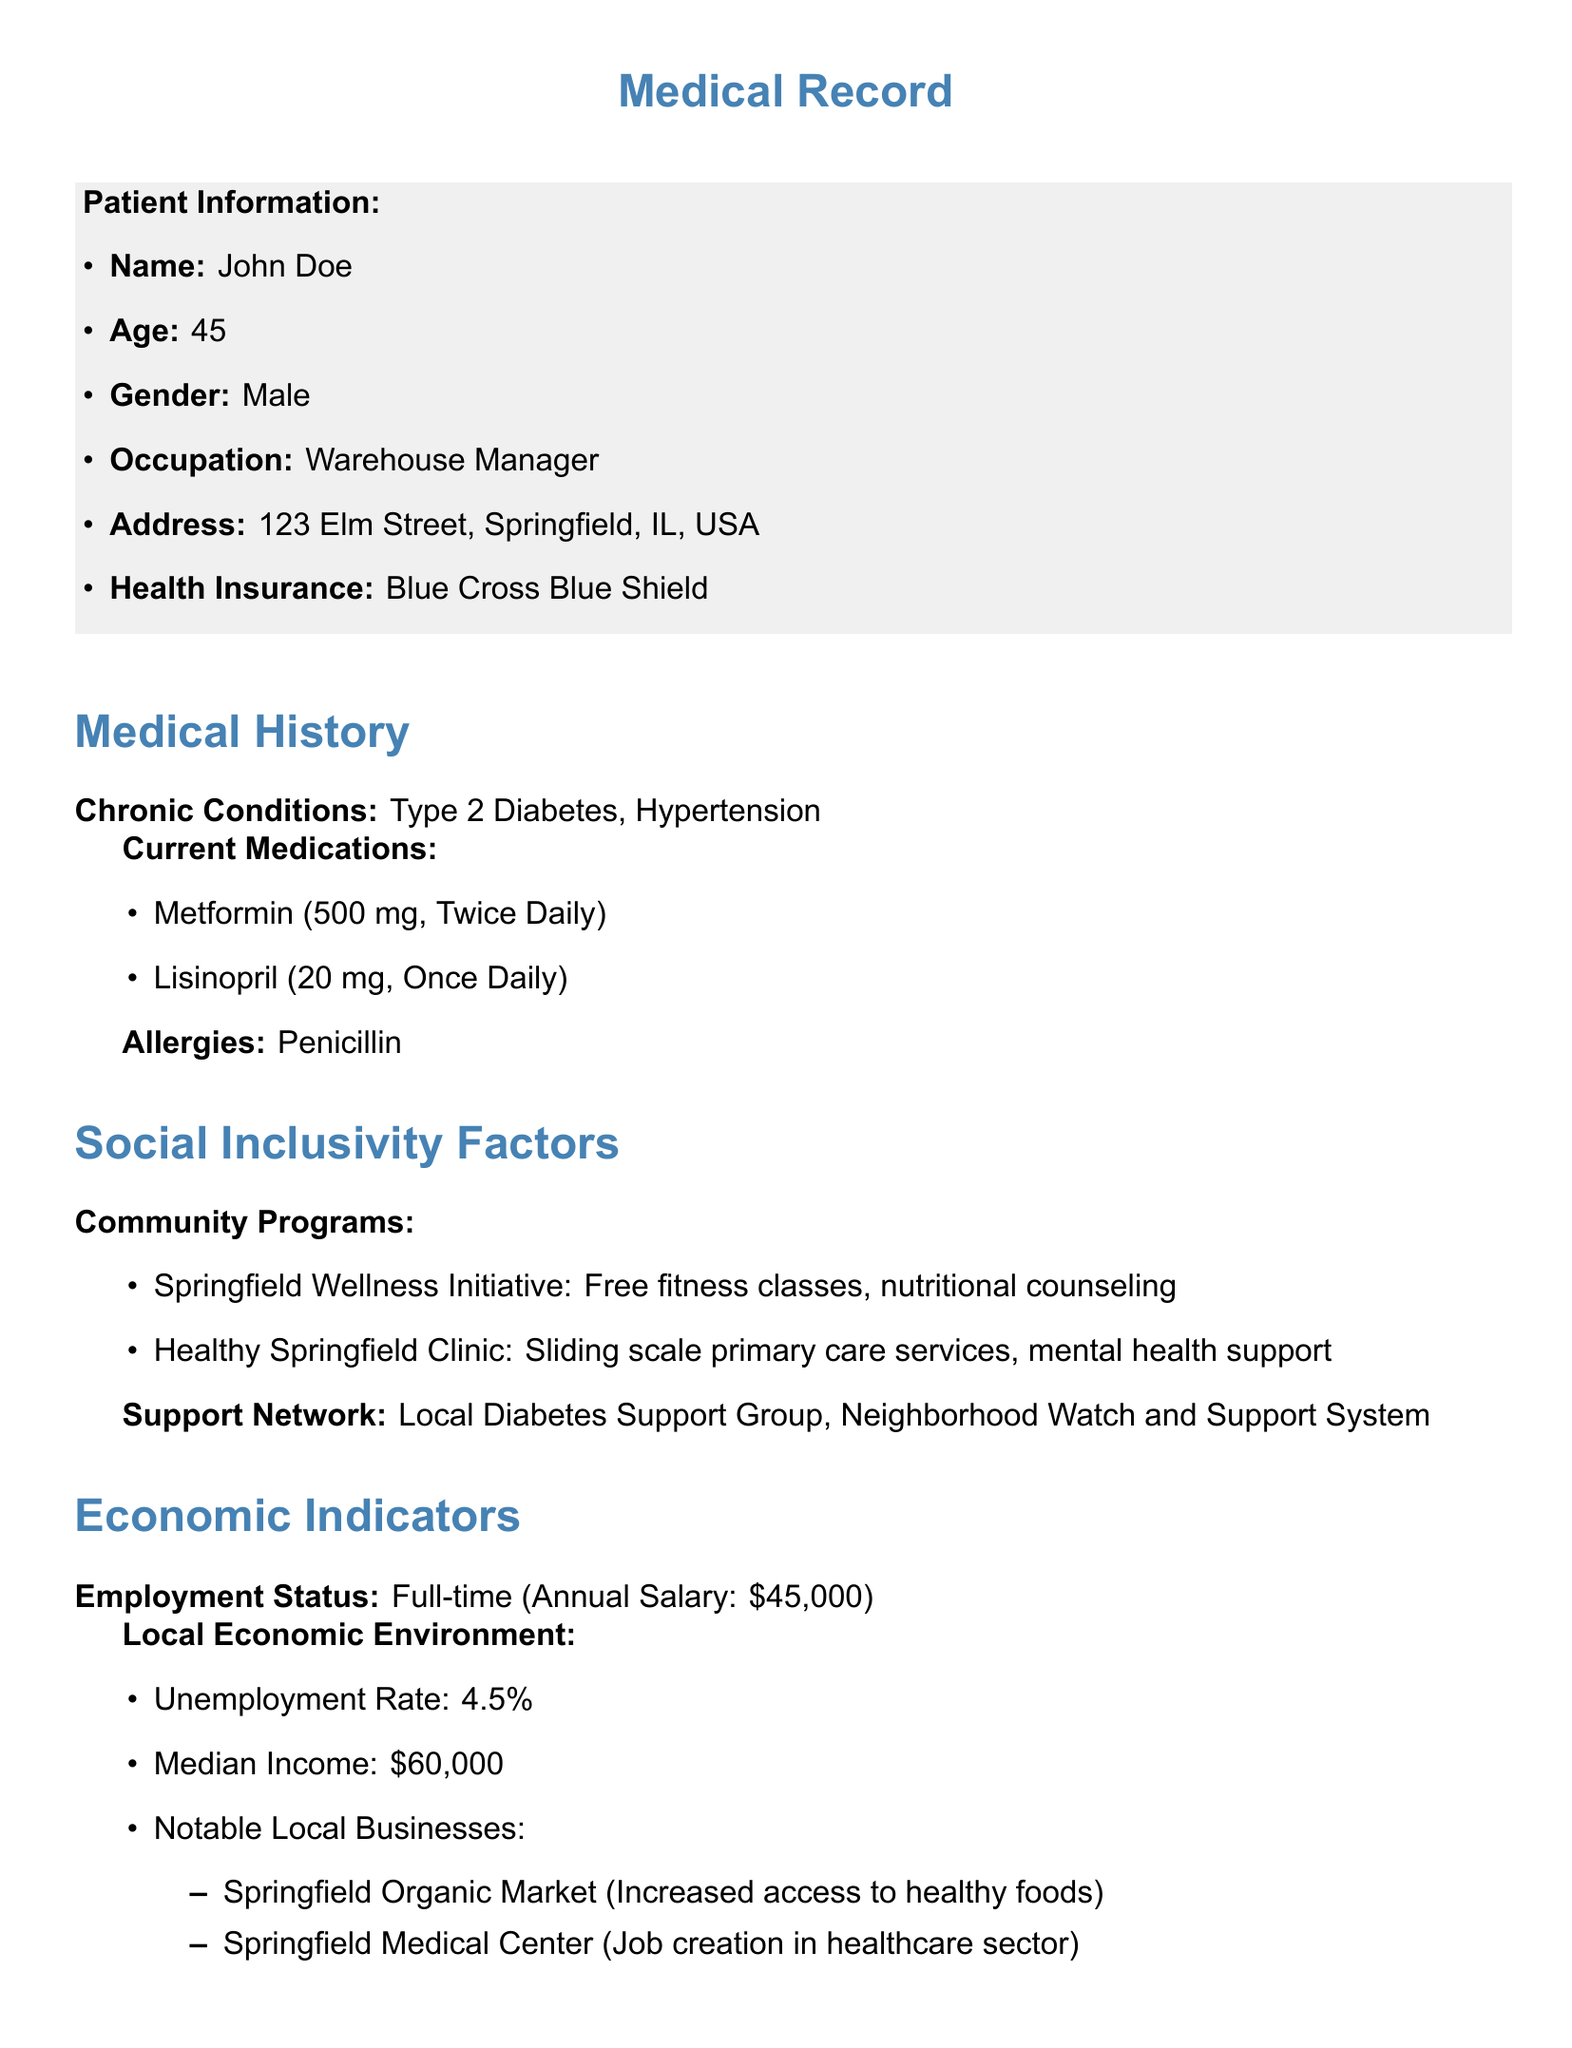What is the patient's name? The patient's name is mentioned in the patient information section.
Answer: John Doe What is the patient's age? The patient's age is listed under patient information.
Answer: 45 What chronic conditions does the patient have? The chronic conditions are specified in the medical history section.
Answer: Type 2 Diabetes, Hypertension What community program offers nutritional counseling? The community program providing nutritional counseling is mentioned in the social inclusivity factors section.
Answer: Springfield Wellness Initiative What is the annual salary of the patient? The patient's employment status and annual salary are detailed under economic indicators.
Answer: $45,000 What health policy is associated with enhancing access to insurance? The health policy related to insurance access is noted in the health policy impact section.
Answer: Affordable Care Act (ACA) What is the local unemployment rate? The local economic environment includes the unemployment rate.
Answer: 4.5% What are the economic benefits mentioned in the document? The economic benefits are detailed under health policy impact.
Answer: Reduction in healthcare costs, Increased labor productivity Which local business increased access to healthy foods? The notable local businesses include the one that increased access to healthy foods.
Answer: Springfield Organic Market 